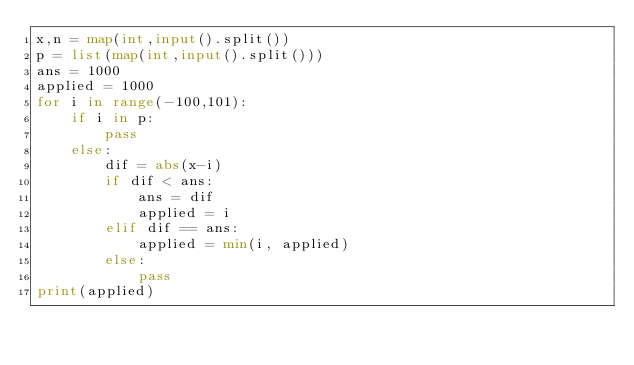<code> <loc_0><loc_0><loc_500><loc_500><_Python_>x,n = map(int,input().split())
p = list(map(int,input().split()))
ans = 1000
applied = 1000
for i in range(-100,101):
    if i in p:
        pass
    else:
        dif = abs(x-i)
        if dif < ans:
            ans = dif
            applied = i
        elif dif == ans:
            applied = min(i, applied)
        else:
            pass
print(applied)</code> 